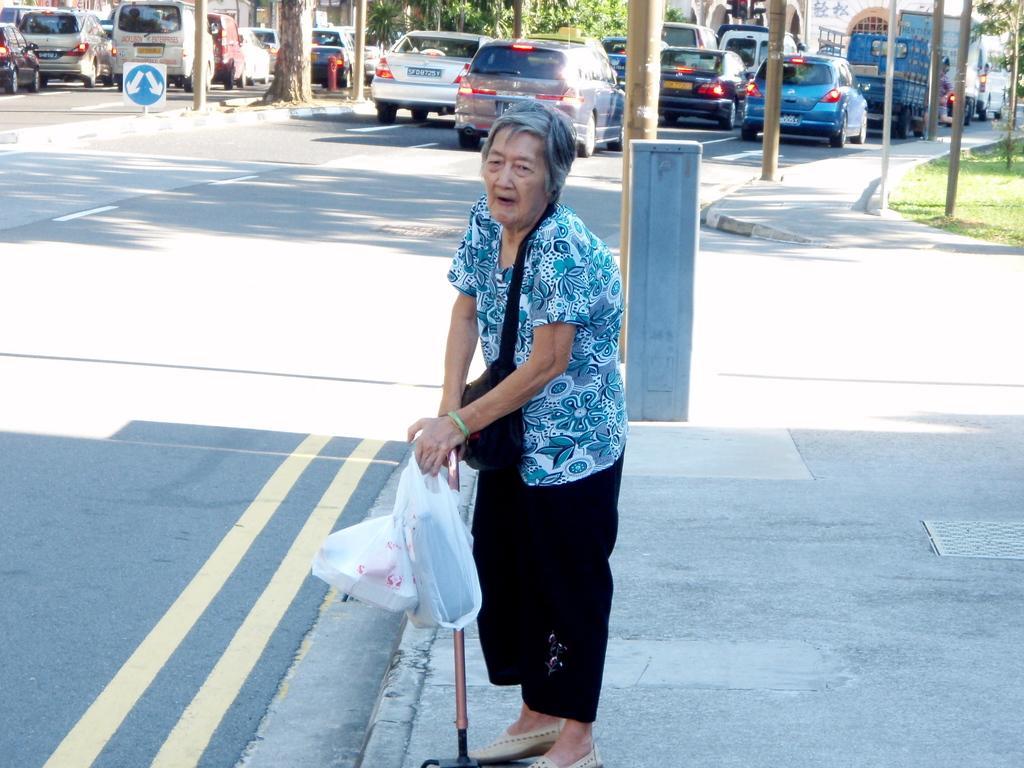Can you describe this image briefly? In the foreground of this image, there is an old woman wearing a bag, holding a walking stick, few covers and standing on the pavement. On the left, there is a road. In the background, there are few trees, poles, pavement, sign board and few vehicles moving on the road. 